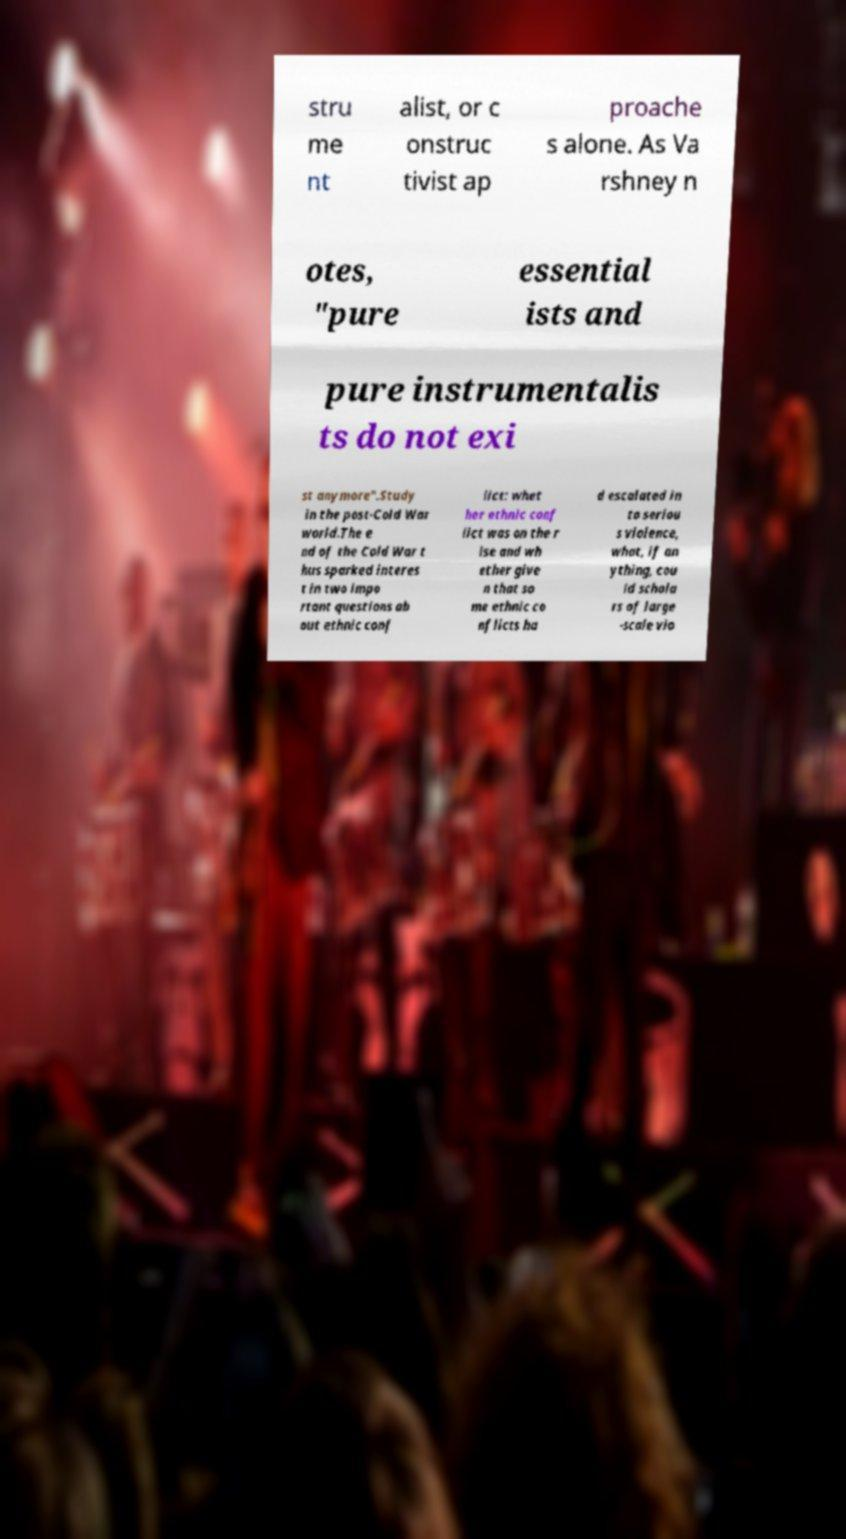I need the written content from this picture converted into text. Can you do that? stru me nt alist, or c onstruc tivist ap proache s alone. As Va rshney n otes, "pure essential ists and pure instrumentalis ts do not exi st anymore".Study in the post-Cold War world.The e nd of the Cold War t hus sparked interes t in two impo rtant questions ab out ethnic conf lict: whet her ethnic conf lict was on the r ise and wh ether give n that so me ethnic co nflicts ha d escalated in to seriou s violence, what, if an ything, cou ld schola rs of large -scale vio 